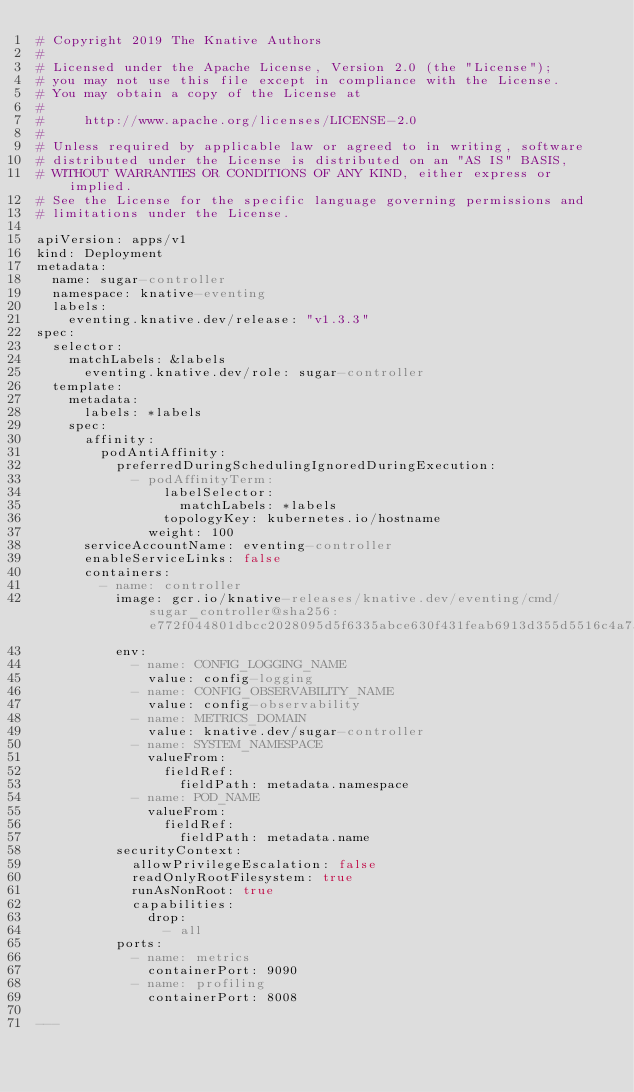Convert code to text. <code><loc_0><loc_0><loc_500><loc_500><_YAML_># Copyright 2019 The Knative Authors
#
# Licensed under the Apache License, Version 2.0 (the "License");
# you may not use this file except in compliance with the License.
# You may obtain a copy of the License at
#
#     http://www.apache.org/licenses/LICENSE-2.0
#
# Unless required by applicable law or agreed to in writing, software
# distributed under the License is distributed on an "AS IS" BASIS,
# WITHOUT WARRANTIES OR CONDITIONS OF ANY KIND, either express or implied.
# See the License for the specific language governing permissions and
# limitations under the License.

apiVersion: apps/v1
kind: Deployment
metadata:
  name: sugar-controller
  namespace: knative-eventing
  labels:
    eventing.knative.dev/release: "v1.3.3"
spec:
  selector:
    matchLabels: &labels
      eventing.knative.dev/role: sugar-controller
  template:
    metadata:
      labels: *labels
    spec:
      affinity:
        podAntiAffinity:
          preferredDuringSchedulingIgnoredDuringExecution:
            - podAffinityTerm:
                labelSelector:
                  matchLabels: *labels
                topologyKey: kubernetes.io/hostname
              weight: 100
      serviceAccountName: eventing-controller
      enableServiceLinks: false
      containers:
        - name: controller
          image: gcr.io/knative-releases/knative.dev/eventing/cmd/sugar_controller@sha256:e772f044801dbcc2028095d5f6335abce630f431feab6913d355d5516c4a7ae8
          env:
            - name: CONFIG_LOGGING_NAME
              value: config-logging
            - name: CONFIG_OBSERVABILITY_NAME
              value: config-observability
            - name: METRICS_DOMAIN
              value: knative.dev/sugar-controller
            - name: SYSTEM_NAMESPACE
              valueFrom:
                fieldRef:
                  fieldPath: metadata.namespace
            - name: POD_NAME
              valueFrom:
                fieldRef:
                  fieldPath: metadata.name
          securityContext:
            allowPrivilegeEscalation: false
            readOnlyRootFilesystem: true
            runAsNonRoot: true
            capabilities:
              drop:
                - all
          ports:
            - name: metrics
              containerPort: 9090
            - name: profiling
              containerPort: 8008

---
</code> 